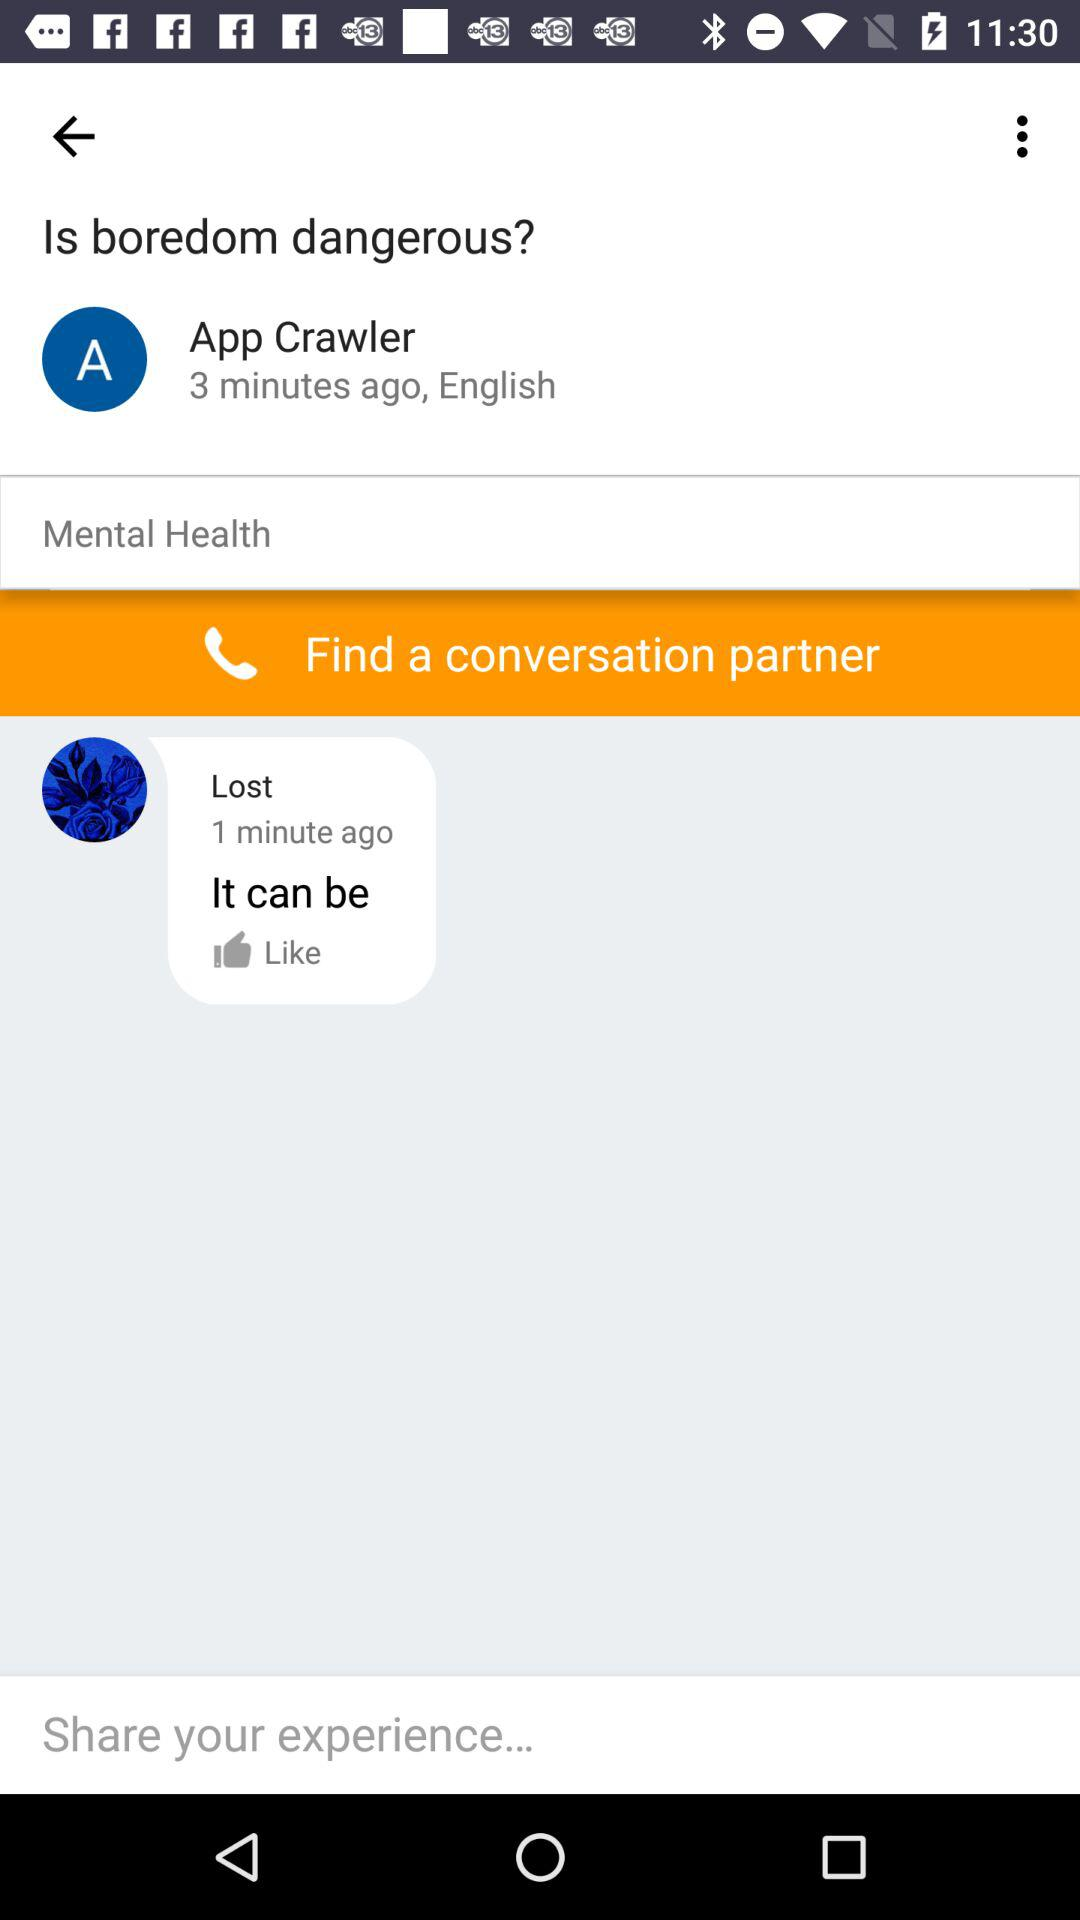What is the user name? The user name is App Crawler. 